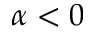<formula> <loc_0><loc_0><loc_500><loc_500>\alpha < 0</formula> 